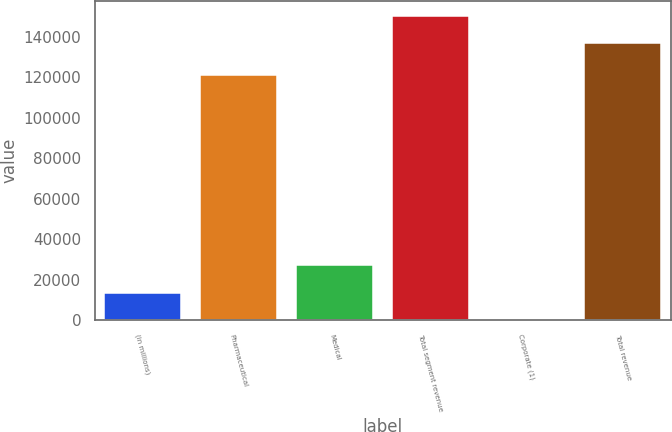Convert chart to OTSL. <chart><loc_0><loc_0><loc_500><loc_500><bar_chart><fcel>(in millions)<fcel>Pharmaceutical<fcel>Medical<fcel>Total segment revenue<fcel>Corporate (1)<fcel>Total revenue<nl><fcel>13693.9<fcel>121241<fcel>27374.8<fcel>150490<fcel>13<fcel>136809<nl></chart> 